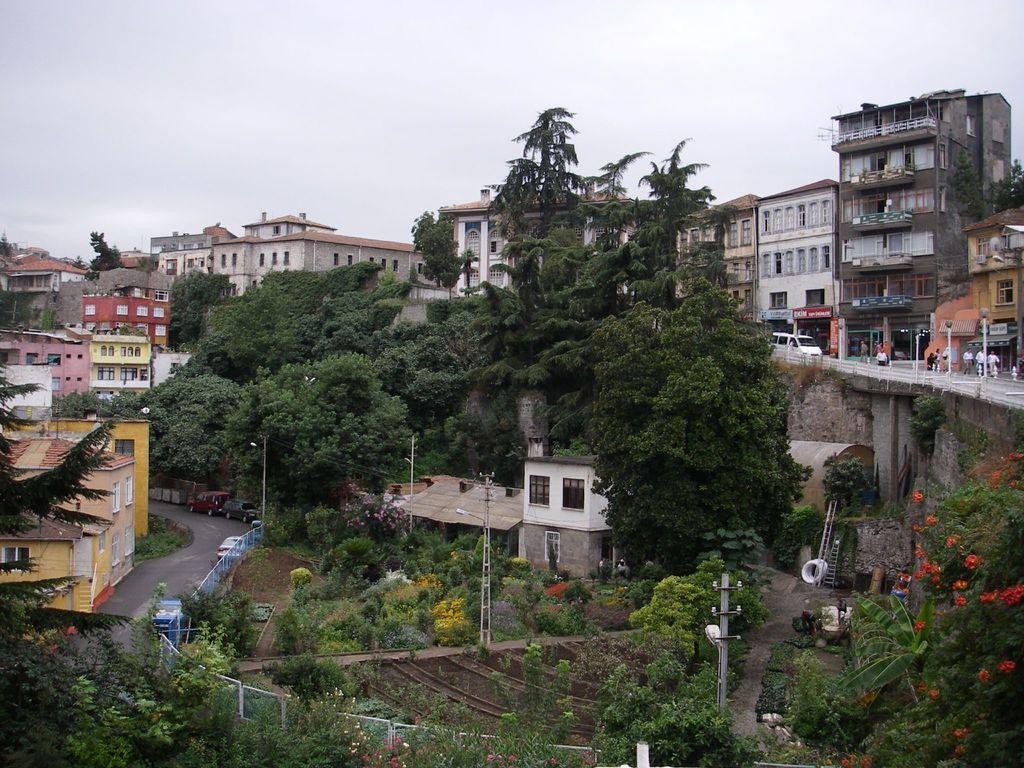How would you summarize this image in a sentence or two? There are some trees and some buildings as we can see at the bottom of this image,and there are some buildings in the background. There are some persons and a white color vehicle on the right side of this image. There is a pole at the bottom of this image and there is a sky at the top of this image. 